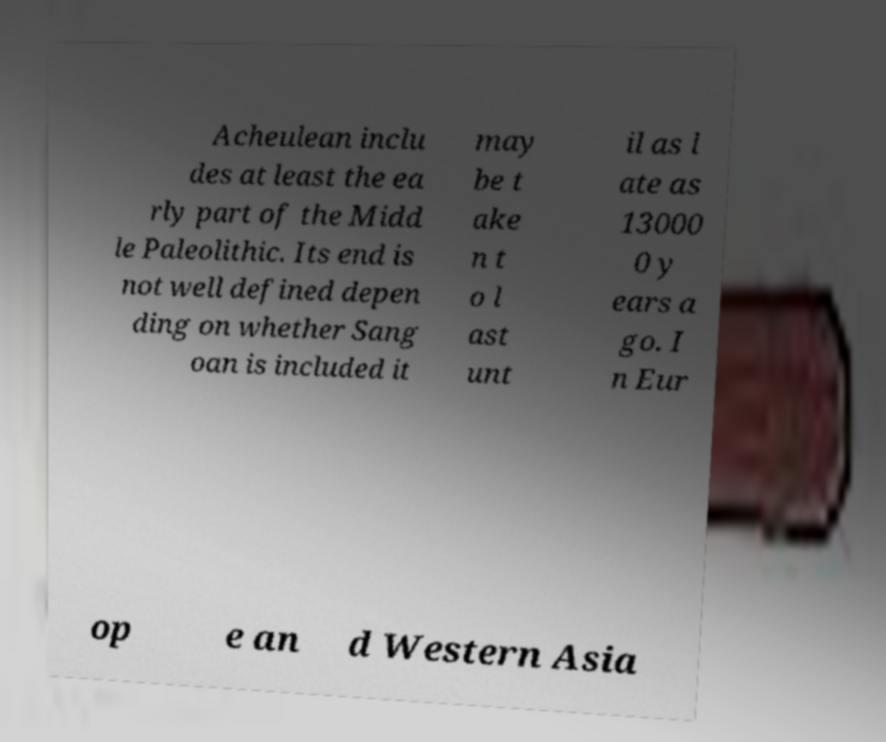I need the written content from this picture converted into text. Can you do that? Acheulean inclu des at least the ea rly part of the Midd le Paleolithic. Its end is not well defined depen ding on whether Sang oan is included it may be t ake n t o l ast unt il as l ate as 13000 0 y ears a go. I n Eur op e an d Western Asia 